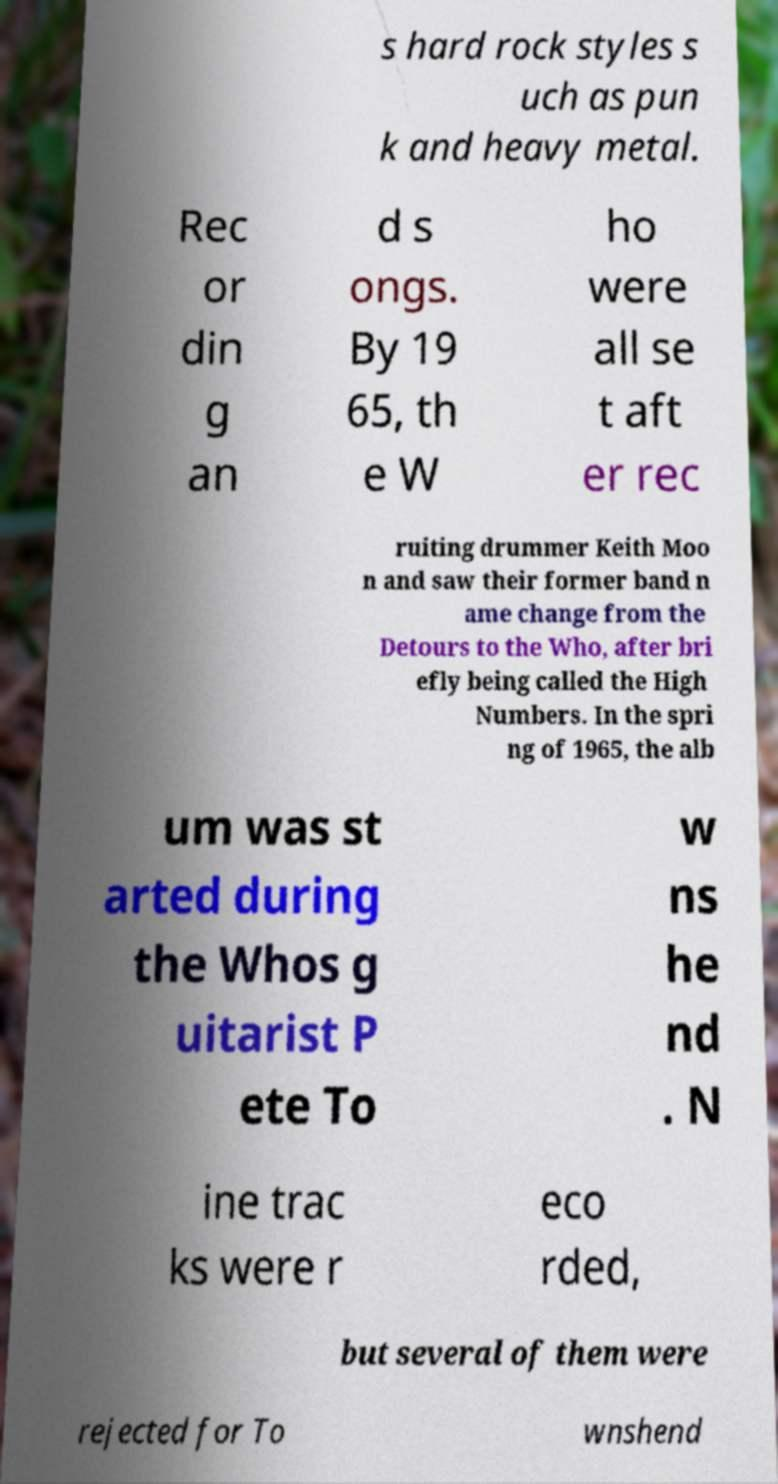What messages or text are displayed in this image? I need them in a readable, typed format. s hard rock styles s uch as pun k and heavy metal. Rec or din g an d s ongs. By 19 65, th e W ho were all se t aft er rec ruiting drummer Keith Moo n and saw their former band n ame change from the Detours to the Who, after bri efly being called the High Numbers. In the spri ng of 1965, the alb um was st arted during the Whos g uitarist P ete To w ns he nd . N ine trac ks were r eco rded, but several of them were rejected for To wnshend 